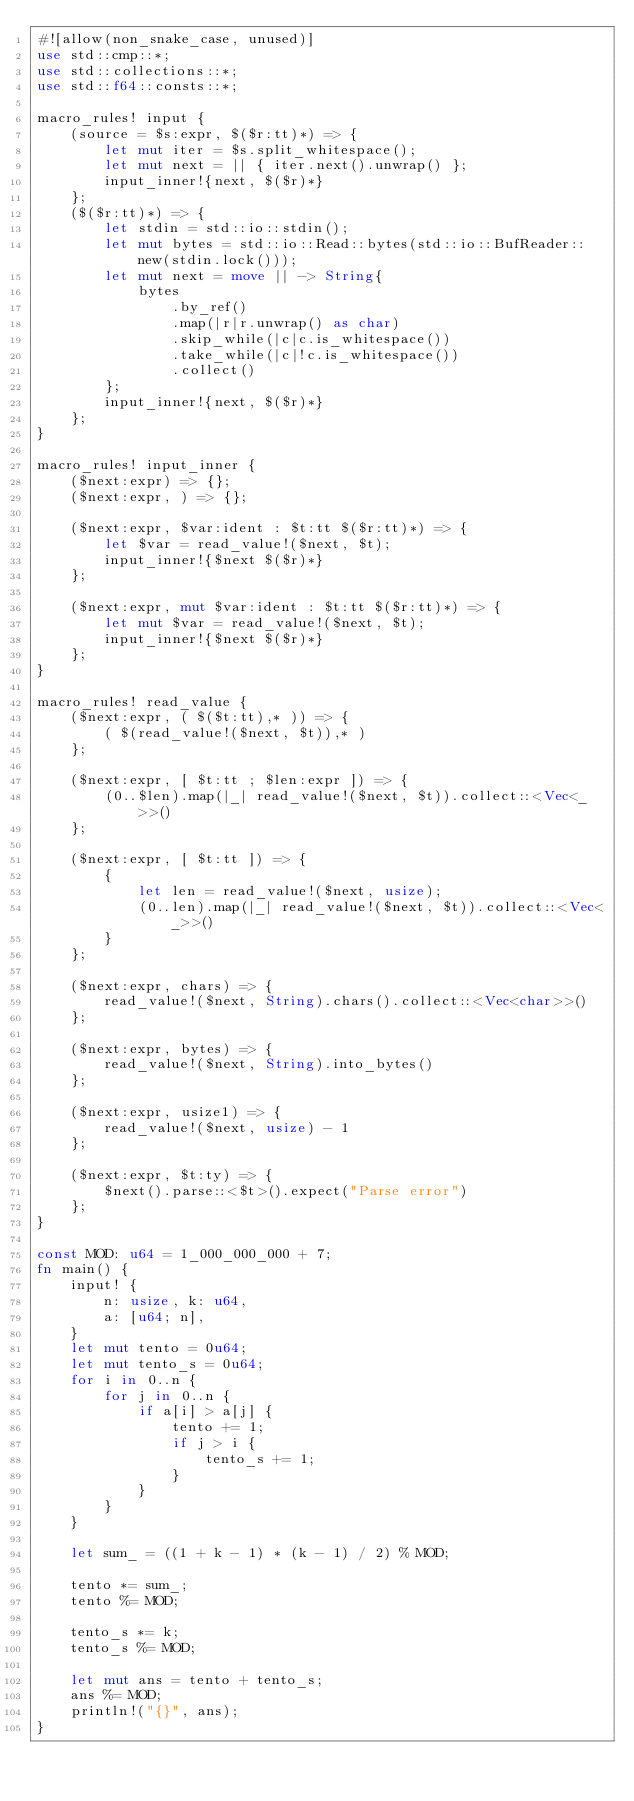<code> <loc_0><loc_0><loc_500><loc_500><_Rust_>#![allow(non_snake_case, unused)]
use std::cmp::*;
use std::collections::*;
use std::f64::consts::*;

macro_rules! input {
    (source = $s:expr, $($r:tt)*) => {
        let mut iter = $s.split_whitespace();
        let mut next = || { iter.next().unwrap() };
        input_inner!{next, $($r)*}
    };
    ($($r:tt)*) => {
        let stdin = std::io::stdin();
        let mut bytes = std::io::Read::bytes(std::io::BufReader::new(stdin.lock()));
        let mut next = move || -> String{
            bytes
                .by_ref()
                .map(|r|r.unwrap() as char)
                .skip_while(|c|c.is_whitespace())
                .take_while(|c|!c.is_whitespace())
                .collect()
        };
        input_inner!{next, $($r)*}
    };
}

macro_rules! input_inner {
    ($next:expr) => {};
    ($next:expr, ) => {};

    ($next:expr, $var:ident : $t:tt $($r:tt)*) => {
        let $var = read_value!($next, $t);
        input_inner!{$next $($r)*}
    };

    ($next:expr, mut $var:ident : $t:tt $($r:tt)*) => {
        let mut $var = read_value!($next, $t);
        input_inner!{$next $($r)*}
    };
}

macro_rules! read_value {
    ($next:expr, ( $($t:tt),* )) => {
        ( $(read_value!($next, $t)),* )
    };

    ($next:expr, [ $t:tt ; $len:expr ]) => {
        (0..$len).map(|_| read_value!($next, $t)).collect::<Vec<_>>()
    };

    ($next:expr, [ $t:tt ]) => {
        {
            let len = read_value!($next, usize);
            (0..len).map(|_| read_value!($next, $t)).collect::<Vec<_>>()
        }
    };

    ($next:expr, chars) => {
        read_value!($next, String).chars().collect::<Vec<char>>()
    };

    ($next:expr, bytes) => {
        read_value!($next, String).into_bytes()
    };

    ($next:expr, usize1) => {
        read_value!($next, usize) - 1
    };

    ($next:expr, $t:ty) => {
        $next().parse::<$t>().expect("Parse error")
    };
}

const MOD: u64 = 1_000_000_000 + 7;
fn main() {
    input! {
        n: usize, k: u64,
        a: [u64; n],
    }
    let mut tento = 0u64;
    let mut tento_s = 0u64;
    for i in 0..n {
        for j in 0..n {
            if a[i] > a[j] {
                tento += 1;
                if j > i {
                    tento_s += 1;
                }
            }
        }
    }

    let sum_ = ((1 + k - 1) * (k - 1) / 2) % MOD;

    tento *= sum_;
    tento %= MOD;

    tento_s *= k;
    tento_s %= MOD;

    let mut ans = tento + tento_s;
    ans %= MOD;
    println!("{}", ans);
}
</code> 